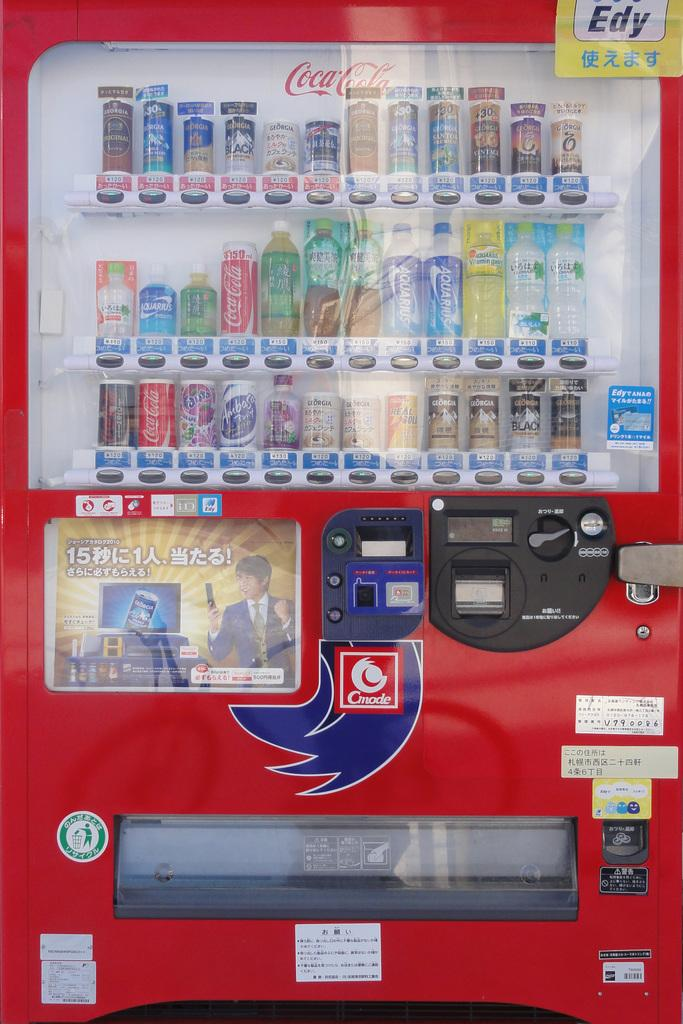What is the main object in the image? There is a vending machine in the vending machine in the image. What can be found inside the vending machine? The vending machine contains tins. What type of scarf is wrapped around the vending machine in the image? There is no scarf present in the image; it only features a vending machine with tins inside. How many frogs can be seen hopping around the vending machine in the image? There are no frogs present in the image; it only features a vending machine with tins inside. 